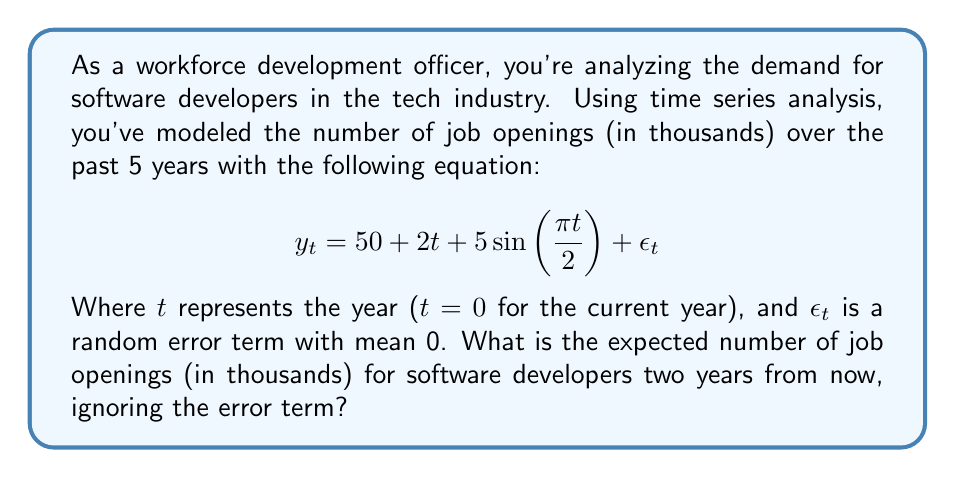Can you solve this math problem? To solve this problem, we'll follow these steps:

1. Identify the components of the time series model:
   - Trend component: $50 + 2t$
   - Seasonal component: $5\sin(\frac{\pi t}{2})$
   - Error term: $\epsilon_t$ (to be ignored as per the question)

2. Determine the value of $t$ for two years from now:
   - Current year: $t = 0$
   - Two years from now: $t = 2$

3. Calculate the trend component for $t = 2$:
   $$50 + 2(2) = 50 + 4 = 54$$

4. Calculate the seasonal component for $t = 2$:
   $$5\sin(\frac{\pi \cdot 2}{2}) = 5\sin(\pi) = 0$$

5. Sum the trend and seasonal components:
   $$54 + 0 = 54$$

Therefore, the expected number of job openings for software developers two years from now is 54 thousand.
Answer: 54 thousand 